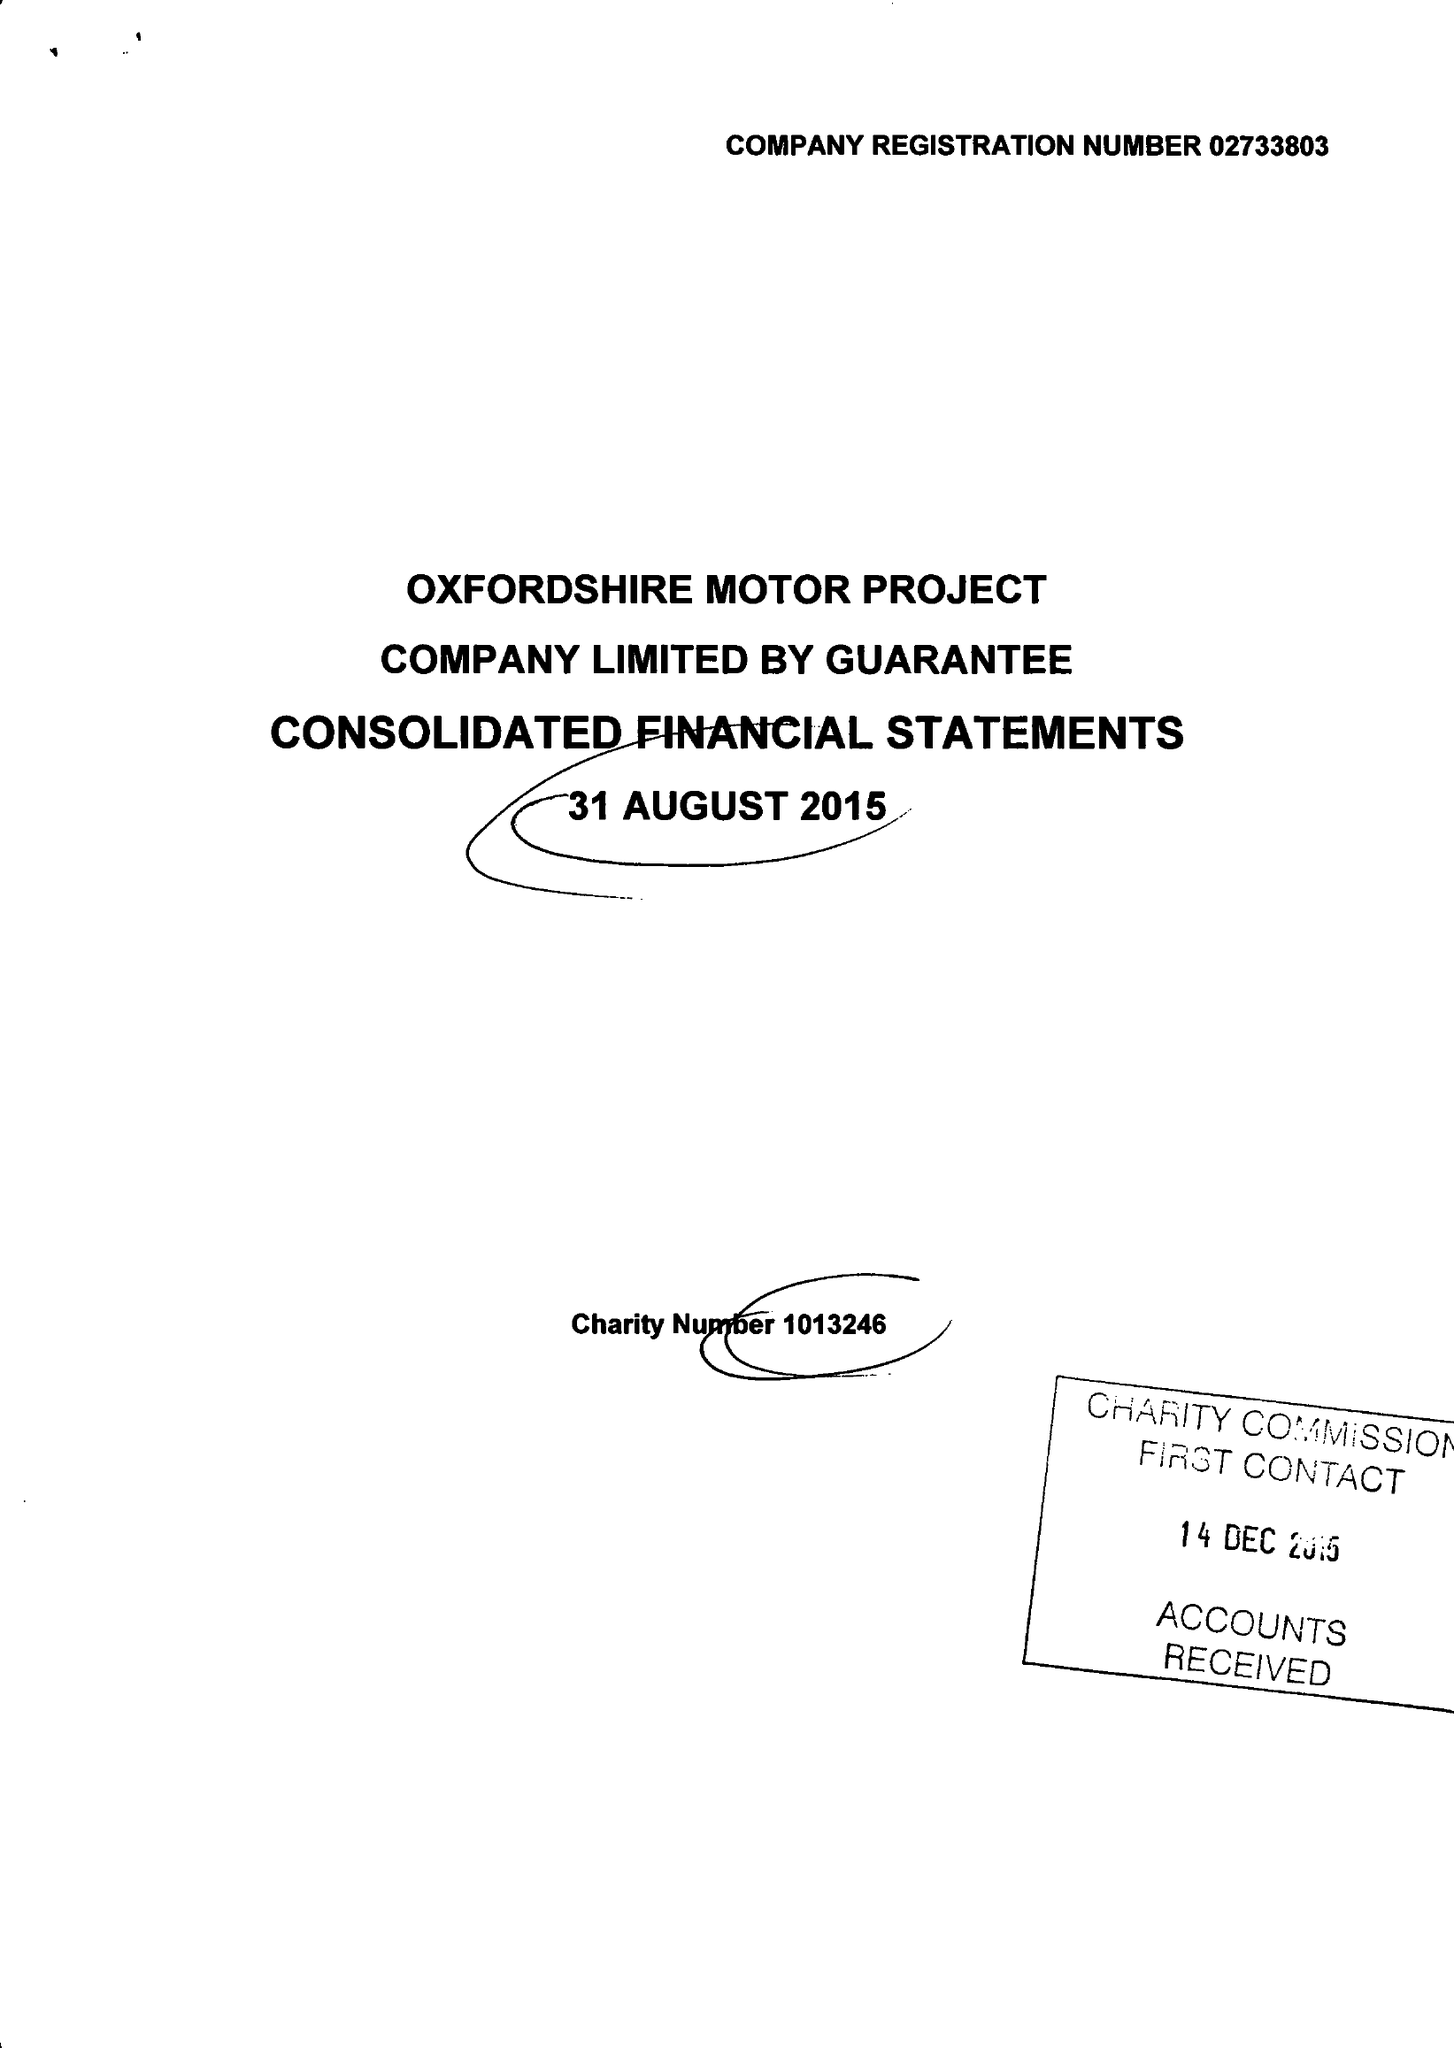What is the value for the charity_number?
Answer the question using a single word or phrase. 1013246 